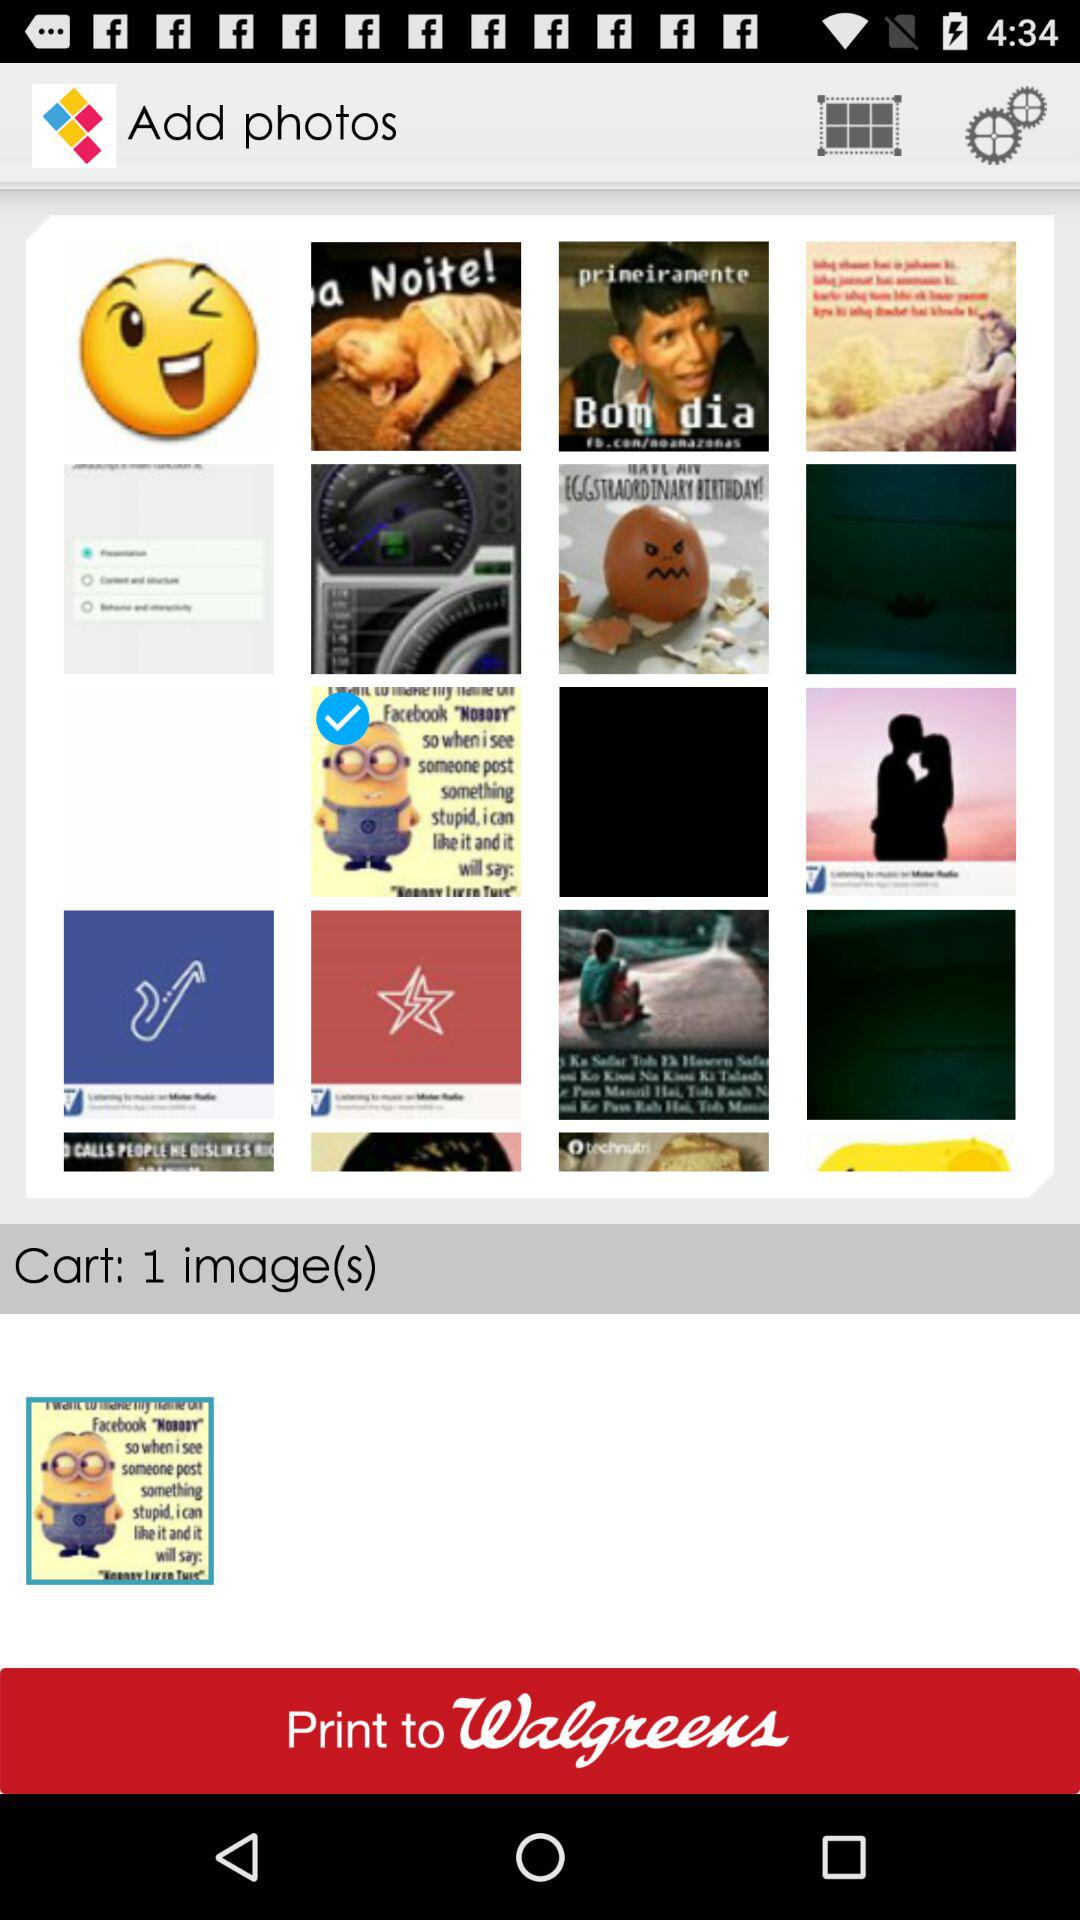What is the number of the image in the cart? The number of the image in the cart is 1. 